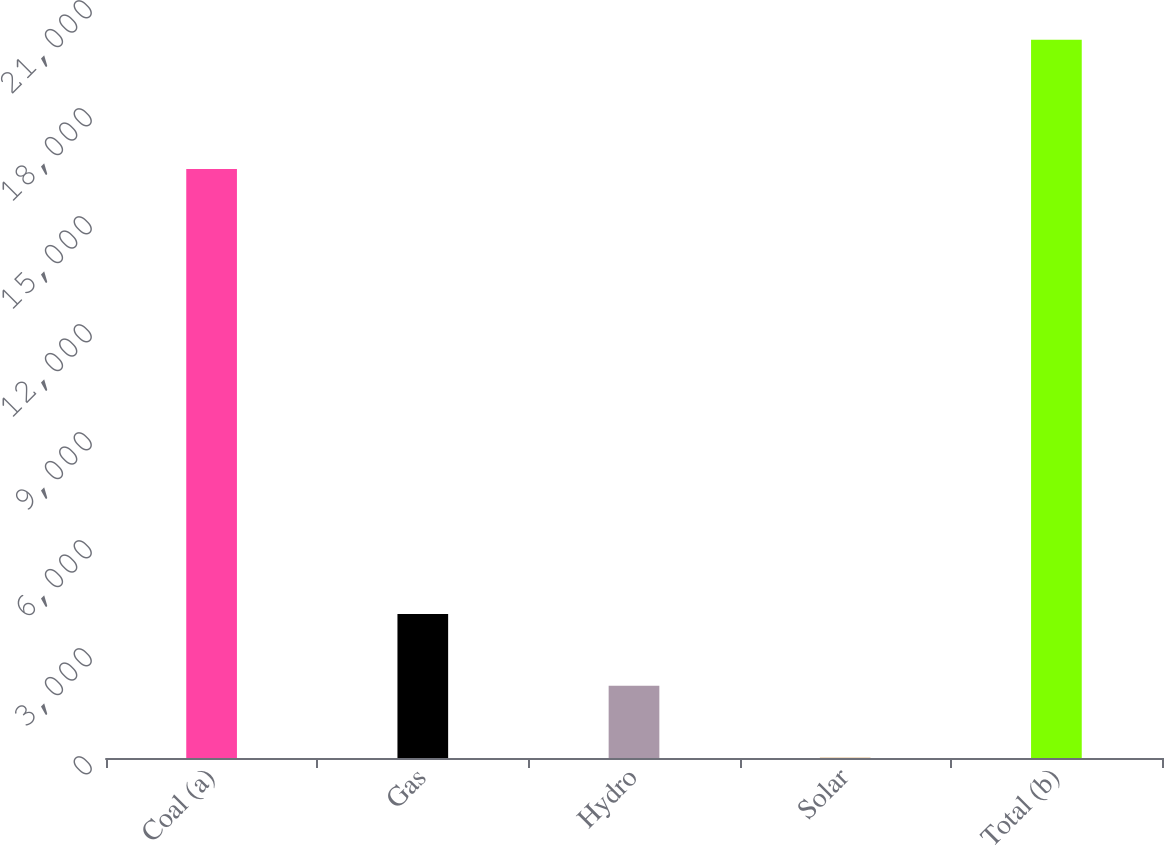Convert chart to OTSL. <chart><loc_0><loc_0><loc_500><loc_500><bar_chart><fcel>Coal (a)<fcel>Gas<fcel>Hydro<fcel>Solar<fcel>Total (b)<nl><fcel>16358<fcel>3998.4<fcel>2004.7<fcel>11<fcel>19948<nl></chart> 